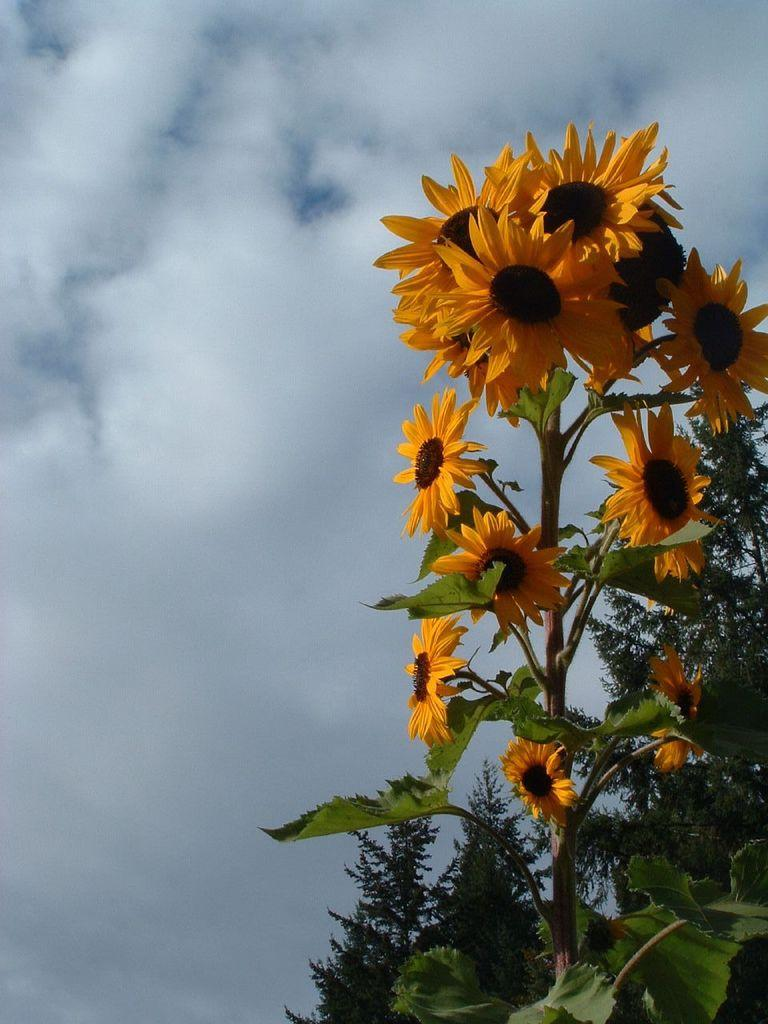What is the main subject of the image? The main subject of the image is a stem. What type of flowers are on the stem? The stem has sunflowers on it. What is the duration of the recess shown in the image? There is no recess present in the image; it features a stem with sunflowers. How does the flight of the birds affect the sunflowers in the image? There are no birds present in the image, so their flight cannot affect the sunflowers. 